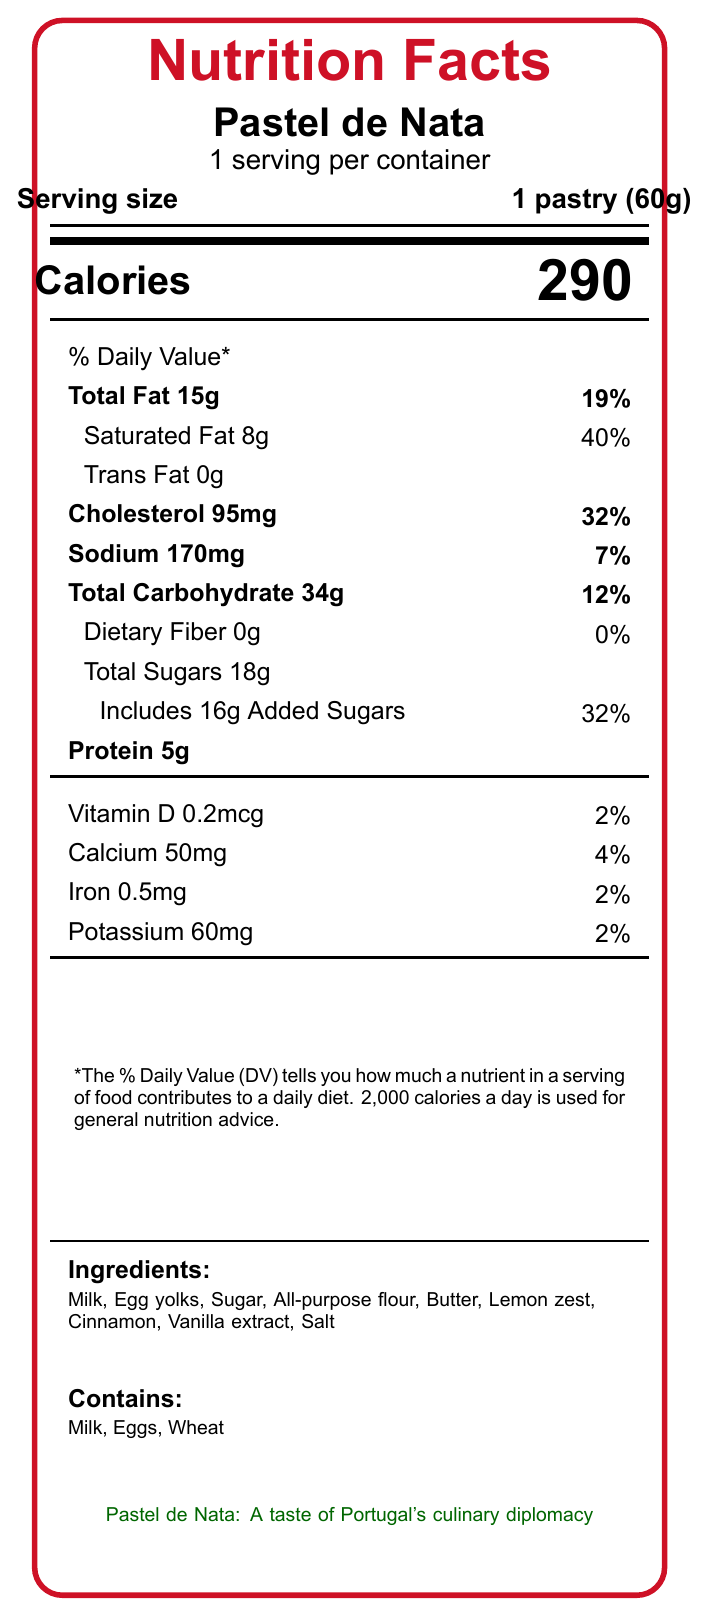what is the serving size for Pastel de Nata? The serving size is displayed near the top of the document, stating "1 pastry (60g)".
Answer: 1 pastry (60g) how many calories are in one serving of Pastel de Nata? The document lists the calorie content as "Calories 290".
Answer: 290 what is the percentage of daily value for saturated fat in Pastel de Nata? The document states "Saturated Fat 8g, 40%" under the Total Fat section.
Answer: 40% how much trans fat does Pastel de Nata contain? The document lists "Trans Fat 0g".
Answer: 0g what are the allergens in Pastel de Nata? The allergens are detailed at the bottom of the document, indicating "Contains: Milk, Eggs, Wheat".
Answer: Milk, Eggs, Wheat what is the primary region of origin for Pastel de Nata? The additional information section states that the pastry originated in Belém, Lisbon.
Answer: Belém, Lisbon which nutrient has the highest daily value percentage in Pastel de Nata? A. Cholesterol B. Saturated Fat C. Sodium D. Total Sugars Saturated Fat has the highest daily value percentage at 40%, compared to Cholesterol (32%), Sodium (7%), and Total Sugars (32%).
Answer: B what is the percentage of daily value for iron in Pastel de Nata? A. 2% B. 4% C. 7% D. 12% The document states "Iron 0.5mg, 2%" in the vitamin and mineral section.
Answer: A does Pastel de Nata contribute significantly to daily carbohydrate intake? The document shows that Pastel de Nata contains 34g of carbohydrates, which is 12% of the daily value, indicating a significant contribution.
Answer: Yes summarize the nutritional profile of Pastel de Nata as presented in the document. The nutritional profile summary includes key nutrient values, ingredients, and allergens detailed in the document.
Answer: Pastel de Nata, a traditional Portuguese pastry, is high in calories (290 per serving), fat (15g total, 8g saturated), and sugars (18g total, 16g added). It contains notable amounts of cholesterol (95mg, 32% daily value) and sodium (170mg, 7% daily value) and provides minimal dietary fiber. It also includes small amounts of protein, vitamin D, calcium, iron, and potassium. The pastry is made with ingredients like milk, egg yolks, sugar, flour, and butter. what is the cultural significance of Pastel de Nata? The document mentions its cultural importance as being iconic and widely enjoyed.
Answer: Iconic Portuguese pastry, popular among tourists and locals what health consideration is suggested for consuming Pastel de Nata? The additional information cautions that Pastel de Nata is high in saturated fat and cholesterol and should be consumed in moderation.
Answer: Consume in moderation due to high saturated fat and cholesterol how much vitamin D is in a serving of Pastel de Nata? The document indicates "Vitamin D 0.2mcg, 2%".
Answer: 0.2mcg is the information about the environmental impact of Pastel de Nata available? The document mentions local sourcing of ingredients for a reduced carbon footprint as a note on sustainability.
Answer: Yes how many servings are in the container of Pastel de Nata? The document specifies "1 serving per container".
Answer: 1 what is the recommended daily calorie intake reference used in the document? The footnote states that 2,000 calories a day is used for general nutrition advice.
Answer: 2,000 calories how does Pastel de Nata contribute to Portugal's economy? The additional information mentions its economic implications related to Portugal’s tourism and food exports.
Answer: Contributes to tourism and food export industries can you determine the exact amount of fiber content in Pastel de Nata? The document indicates "Dietary Fiber 0g".
Answer: 0g what is the amount of potassium in Pastel de Nata? The nutrition facts section shows "Potassium 60mg, 2%".
Answer: 60mg what is the textual description under "Pastel de Nata: A taste of Portugal's culinary diplomacy"? This specific text is in a different green color and indicates culinary diplomacy importance, but the exact content is not part of typical nutrition facts details.
Answer: Cannot be determined what ingredient is used to enhance flavor in Pastel de Nata? The ingredients list includes these items used for flavor enhancement.
Answer: Lemon zest, Cinnamon, Vanilla extract 